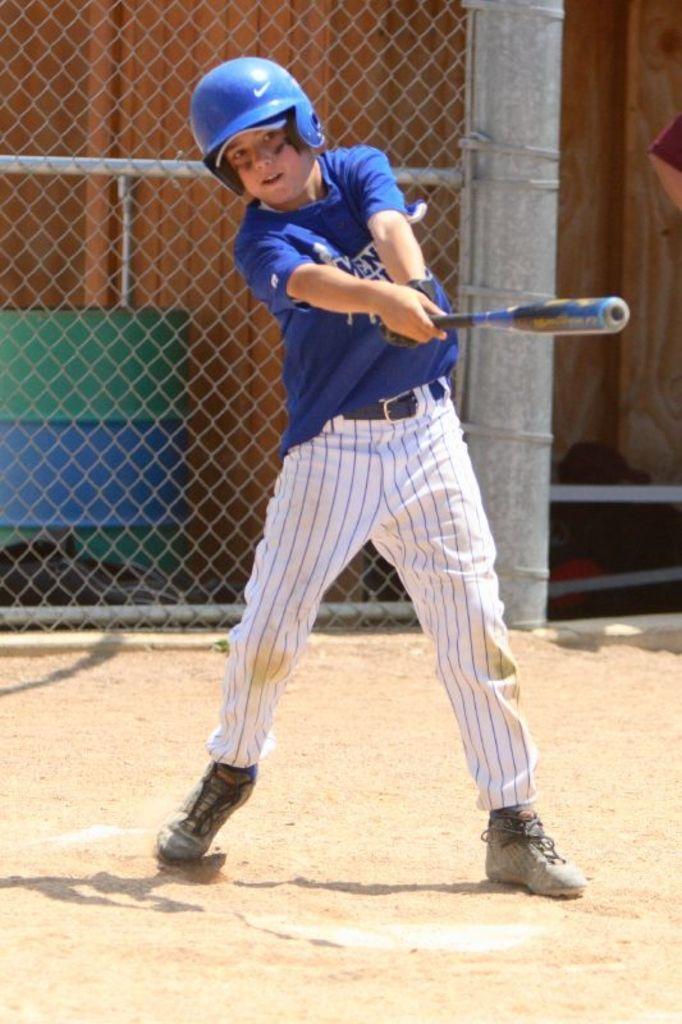Could you give a brief overview of what you see in this image? Here in this picture we can see a child standing on the ground and swinging the bat present in his hand and we can see he is wearing helmet and behind him we can see fencing present over there. 